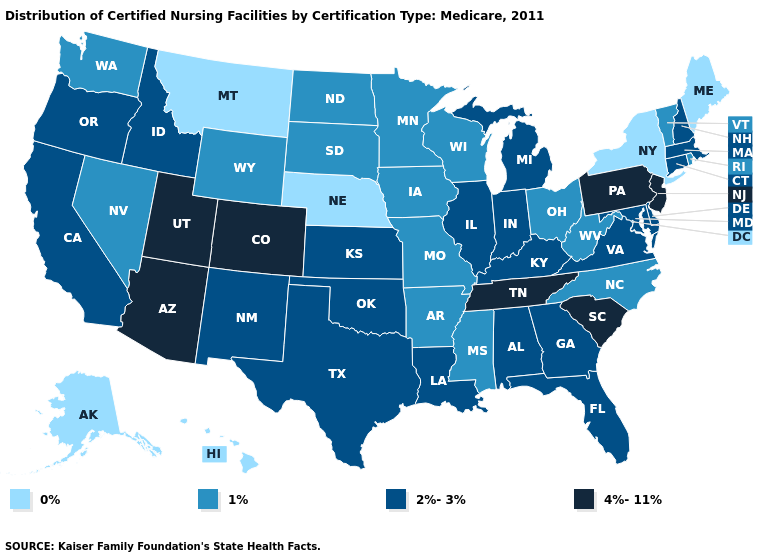Which states have the lowest value in the USA?
Keep it brief. Alaska, Hawaii, Maine, Montana, Nebraska, New York. Does Arizona have the highest value in the USA?
Keep it brief. Yes. Among the states that border Rhode Island , which have the lowest value?
Answer briefly. Connecticut, Massachusetts. What is the highest value in states that border Maine?
Be succinct. 2%-3%. What is the value of South Dakota?
Short answer required. 1%. What is the lowest value in the USA?
Answer briefly. 0%. Does the map have missing data?
Answer briefly. No. What is the highest value in the South ?
Give a very brief answer. 4%-11%. Does Alabama have a higher value than Rhode Island?
Concise answer only. Yes. What is the value of Connecticut?
Short answer required. 2%-3%. What is the lowest value in the South?
Keep it brief. 1%. Which states have the highest value in the USA?
Quick response, please. Arizona, Colorado, New Jersey, Pennsylvania, South Carolina, Tennessee, Utah. Which states have the highest value in the USA?
Short answer required. Arizona, Colorado, New Jersey, Pennsylvania, South Carolina, Tennessee, Utah. How many symbols are there in the legend?
Quick response, please. 4. What is the lowest value in states that border Wisconsin?
Quick response, please. 1%. 